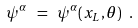<formula> <loc_0><loc_0><loc_500><loc_500>\psi ^ { \alpha } \ = \ \psi ^ { \alpha } ( x _ { L } , \theta ) \ .</formula> 